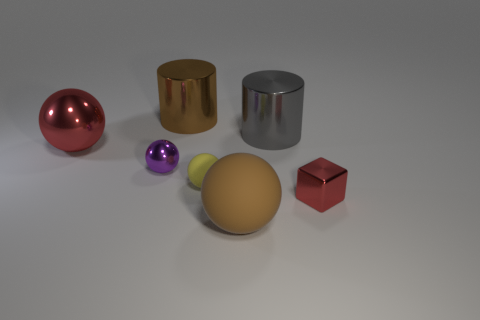Is the number of tiny shiny cubes left of the block greater than the number of gray cylinders that are in front of the tiny yellow sphere?
Keep it short and to the point. No. What shape is the big metallic object that is both on the right side of the big red object and left of the large brown rubber ball?
Ensure brevity in your answer.  Cylinder. The large shiny object on the left side of the purple metallic object has what shape?
Make the answer very short. Sphere. There is a metal sphere in front of the large sphere on the left side of the brown object in front of the big red shiny sphere; how big is it?
Provide a short and direct response. Small. Is the yellow thing the same shape as the large red object?
Provide a short and direct response. Yes. There is a metallic thing that is both left of the large gray cylinder and right of the purple metal thing; what size is it?
Keep it short and to the point. Large. What material is the other purple object that is the same shape as the tiny rubber thing?
Keep it short and to the point. Metal. What material is the red object left of the gray metallic cylinder that is on the right side of the yellow thing?
Provide a succinct answer. Metal. There is a yellow rubber thing; does it have the same shape as the brown thing in front of the purple metallic ball?
Offer a very short reply. Yes. What number of metal objects are either tiny brown spheres or big gray cylinders?
Your answer should be compact. 1. 